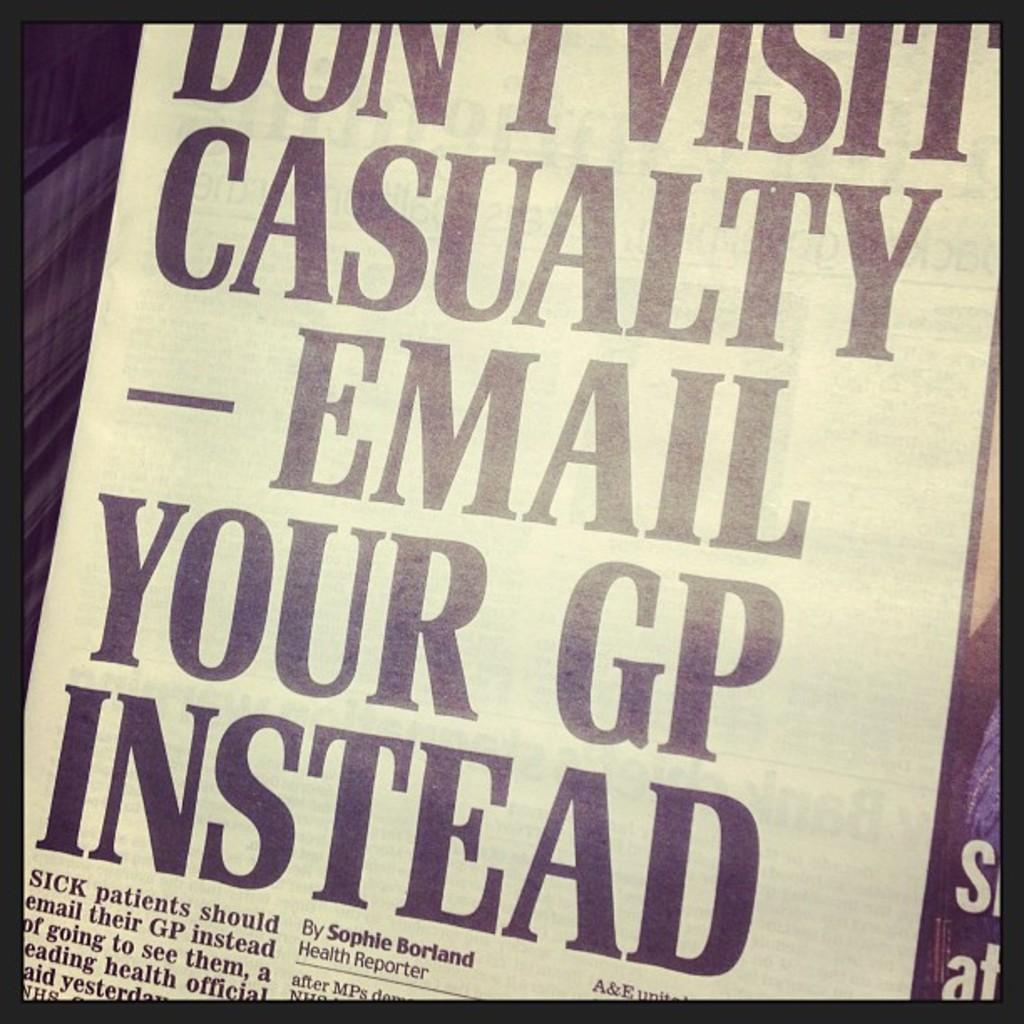Provide a one-sentence caption for the provided image. Paper that says "Don't visit casualty email your GP instead". 